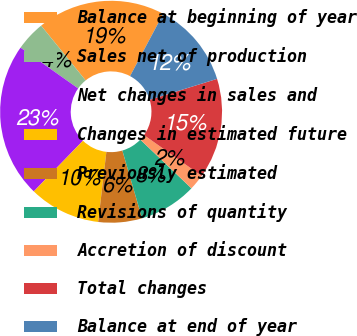Convert chart to OTSL. <chart><loc_0><loc_0><loc_500><loc_500><pie_chart><fcel>Balance at beginning of year<fcel>Sales net of production<fcel>Net changes in sales and<fcel>Changes in estimated future<fcel>Previously estimated<fcel>Revisions of quantity<fcel>Accretion of discount<fcel>Total changes<fcel>Balance at end of year<nl><fcel>18.64%<fcel>4.34%<fcel>22.54%<fcel>10.4%<fcel>6.36%<fcel>8.38%<fcel>2.31%<fcel>14.6%<fcel>12.43%<nl></chart> 